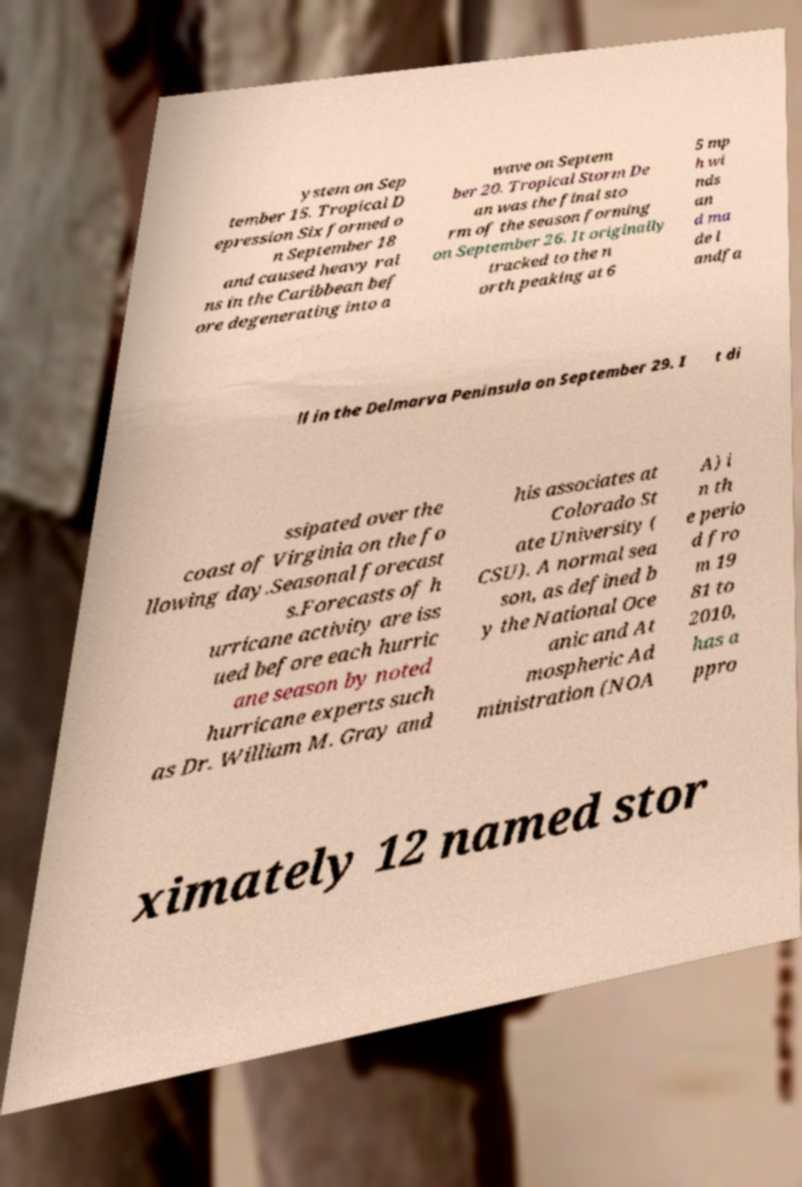There's text embedded in this image that I need extracted. Can you transcribe it verbatim? ystem on Sep tember 15. Tropical D epression Six formed o n September 18 and caused heavy rai ns in the Caribbean bef ore degenerating into a wave on Septem ber 20. Tropical Storm De an was the final sto rm of the season forming on September 26. It originally tracked to the n orth peaking at 6 5 mp h wi nds an d ma de l andfa ll in the Delmarva Peninsula on September 29. I t di ssipated over the coast of Virginia on the fo llowing day.Seasonal forecast s.Forecasts of h urricane activity are iss ued before each hurric ane season by noted hurricane experts such as Dr. William M. Gray and his associates at Colorado St ate University ( CSU). A normal sea son, as defined b y the National Oce anic and At mospheric Ad ministration (NOA A) i n th e perio d fro m 19 81 to 2010, has a ppro ximately 12 named stor 